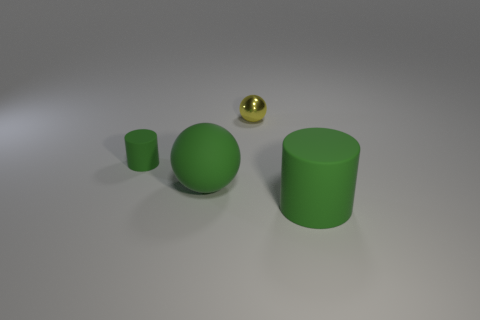Add 1 purple rubber things. How many objects exist? 5 Subtract 0 gray balls. How many objects are left? 4 Subtract all big green spheres. Subtract all green rubber things. How many objects are left? 0 Add 3 matte balls. How many matte balls are left? 4 Add 1 tiny blue shiny spheres. How many tiny blue shiny spheres exist? 1 